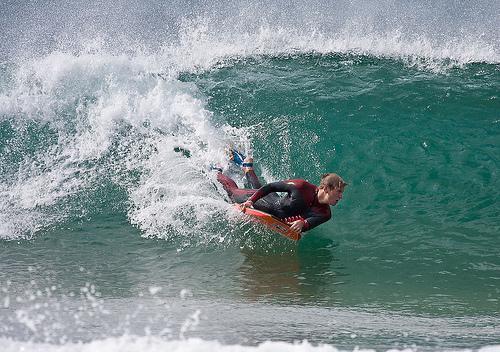How many surfers?
Give a very brief answer. 1. 